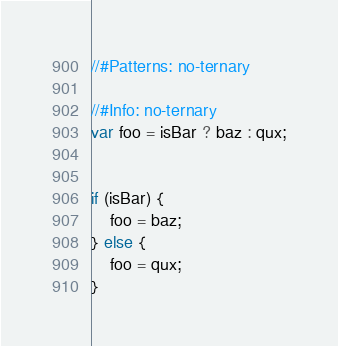<code> <loc_0><loc_0><loc_500><loc_500><_JavaScript_>//#Patterns: no-ternary

//#Info: no-ternary
var foo = isBar ? baz : qux;


if (isBar) {
    foo = baz;
} else {
    foo = qux;
}
</code> 